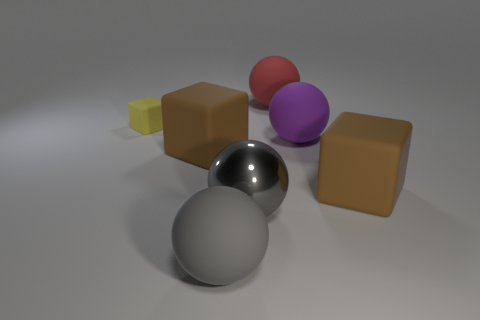Subtract all big rubber spheres. How many spheres are left? 1 Add 3 shiny objects. How many objects exist? 10 Subtract all gray balls. How many balls are left? 2 Subtract all blocks. How many objects are left? 4 Subtract 3 blocks. How many blocks are left? 0 Subtract all cyan spheres. Subtract all gray blocks. How many spheres are left? 4 Subtract all blue blocks. How many green spheres are left? 0 Subtract all tiny yellow metallic cylinders. Subtract all red matte spheres. How many objects are left? 6 Add 1 blocks. How many blocks are left? 4 Add 7 purple spheres. How many purple spheres exist? 8 